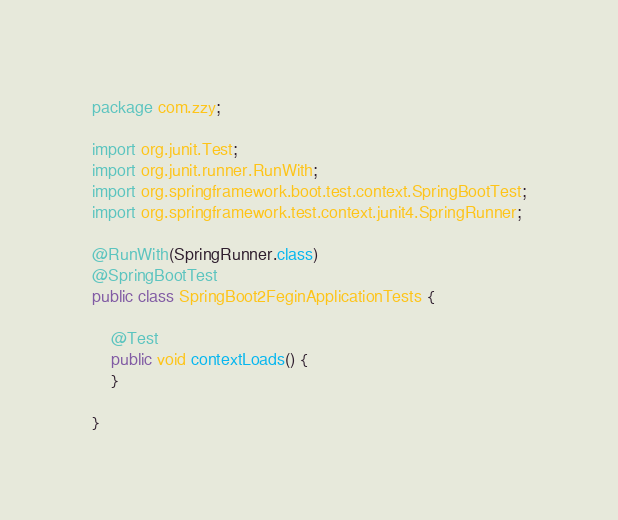Convert code to text. <code><loc_0><loc_0><loc_500><loc_500><_Java_>package com.zzy;

import org.junit.Test;
import org.junit.runner.RunWith;
import org.springframework.boot.test.context.SpringBootTest;
import org.springframework.test.context.junit4.SpringRunner;

@RunWith(SpringRunner.class)
@SpringBootTest
public class SpringBoot2FeginApplicationTests {

    @Test
    public void contextLoads() {
    }

}
</code> 